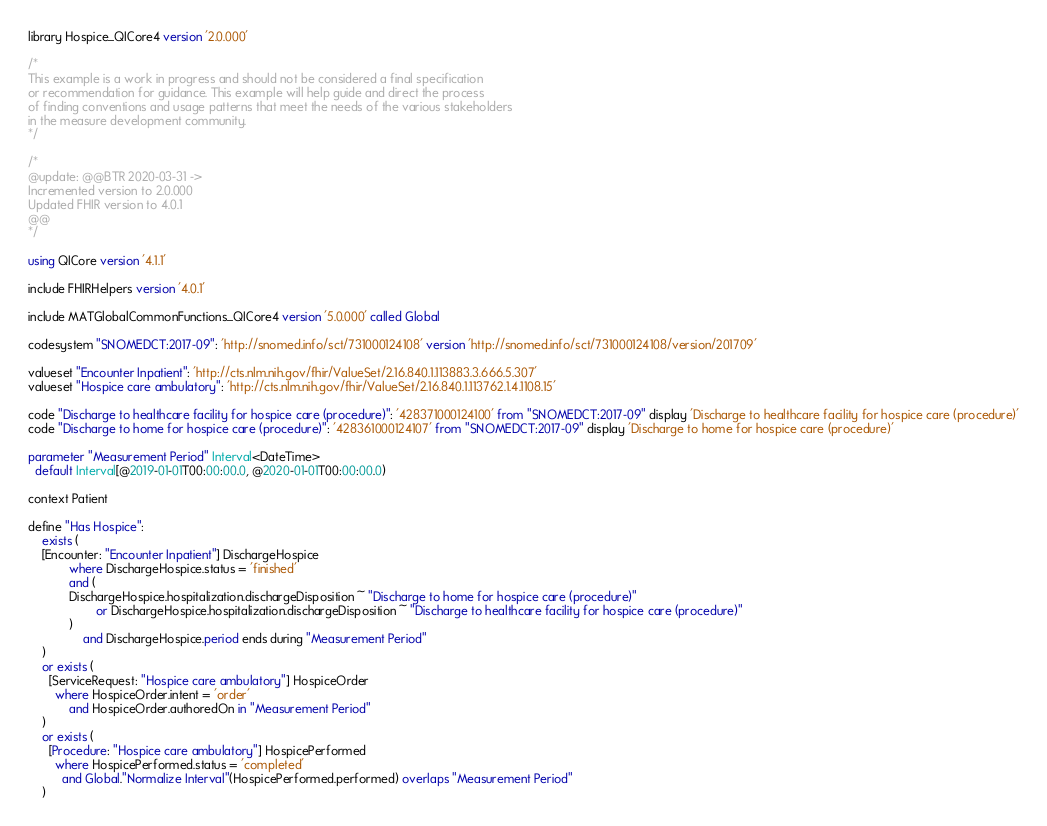<code> <loc_0><loc_0><loc_500><loc_500><_SQL_>library Hospice_QICore4 version '2.0.000'

/*
This example is a work in progress and should not be considered a final specification
or recommendation for guidance. This example will help guide and direct the process
of finding conventions and usage patterns that meet the needs of the various stakeholders
in the measure development community.
*/

/*
@update: @@BTR 2020-03-31 ->
Incremented version to 2.0.000
Updated FHIR version to 4.0.1
@@
*/

using QICore version '4.1.1'

include FHIRHelpers version '4.0.1'

include MATGlobalCommonFunctions_QICore4 version '5.0.000' called Global

codesystem "SNOMEDCT:2017-09": 'http://snomed.info/sct/731000124108' version 'http://snomed.info/sct/731000124108/version/201709'

valueset "Encounter Inpatient": 'http://cts.nlm.nih.gov/fhir/ValueSet/2.16.840.1.113883.3.666.5.307'
valueset "Hospice care ambulatory": 'http://cts.nlm.nih.gov/fhir/ValueSet/2.16.840.1.113762.1.4.1108.15'

code "Discharge to healthcare facility for hospice care (procedure)": '428371000124100' from "SNOMEDCT:2017-09" display 'Discharge to healthcare facility for hospice care (procedure)'
code "Discharge to home for hospice care (procedure)": '428361000124107' from "SNOMEDCT:2017-09" display 'Discharge to home for hospice care (procedure)'

parameter "Measurement Period" Interval<DateTime>
  default Interval[@2019-01-01T00:00:00.0, @2020-01-01T00:00:00.0)

context Patient

define "Has Hospice":
	exists (
    [Encounter: "Encounter Inpatient"] DischargeHospice
			where DischargeHospice.status = 'finished'
		    and (
	        DischargeHospice.hospitalization.dischargeDisposition ~ "Discharge to home for hospice care (procedure)"
				    or DischargeHospice.hospitalization.dischargeDisposition ~ "Discharge to healthcare facility for hospice care (procedure)"
	    	)
				and DischargeHospice.period ends during "Measurement Period"
	)
    or exists (
      [ServiceRequest: "Hospice care ambulatory"] HospiceOrder
        where HospiceOrder.intent = 'order'
            and HospiceOrder.authoredOn in "Measurement Period"
    )
    or exists (
      [Procedure: "Hospice care ambulatory"] HospicePerformed
        where HospicePerformed.status = 'completed'
          and Global."Normalize Interval"(HospicePerformed.performed) overlaps "Measurement Period"
    )
</code> 